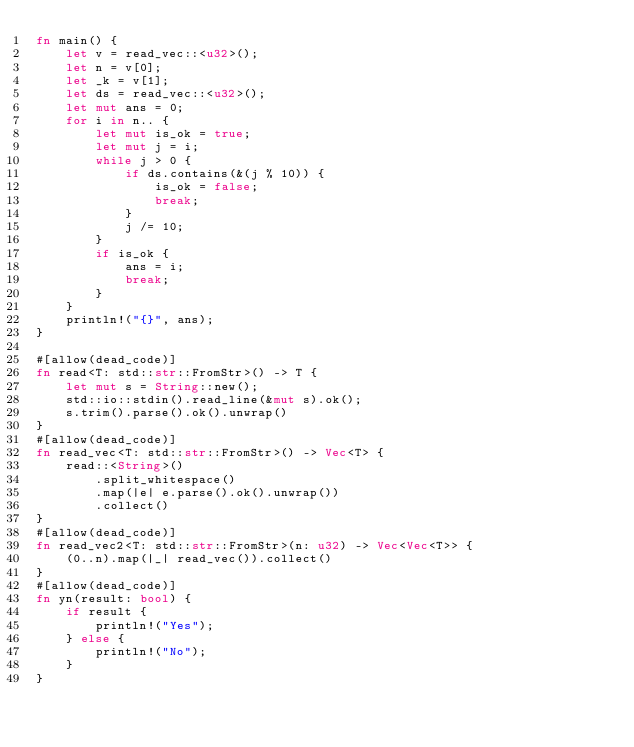Convert code to text. <code><loc_0><loc_0><loc_500><loc_500><_Rust_>fn main() {
    let v = read_vec::<u32>();
    let n = v[0];
    let _k = v[1];
    let ds = read_vec::<u32>();
    let mut ans = 0;
    for i in n.. {
        let mut is_ok = true;
        let mut j = i;
        while j > 0 {
            if ds.contains(&(j % 10)) {
                is_ok = false;
                break;
            }
            j /= 10;
        }
        if is_ok {
            ans = i;
            break;
        }
    }
    println!("{}", ans);
}

#[allow(dead_code)]
fn read<T: std::str::FromStr>() -> T {
    let mut s = String::new();
    std::io::stdin().read_line(&mut s).ok();
    s.trim().parse().ok().unwrap()
}
#[allow(dead_code)]
fn read_vec<T: std::str::FromStr>() -> Vec<T> {
    read::<String>()
        .split_whitespace()
        .map(|e| e.parse().ok().unwrap())
        .collect()
}
#[allow(dead_code)]
fn read_vec2<T: std::str::FromStr>(n: u32) -> Vec<Vec<T>> {
    (0..n).map(|_| read_vec()).collect()
}
#[allow(dead_code)]
fn yn(result: bool) {
    if result {
        println!("Yes");
    } else {
        println!("No");
    }
}
</code> 